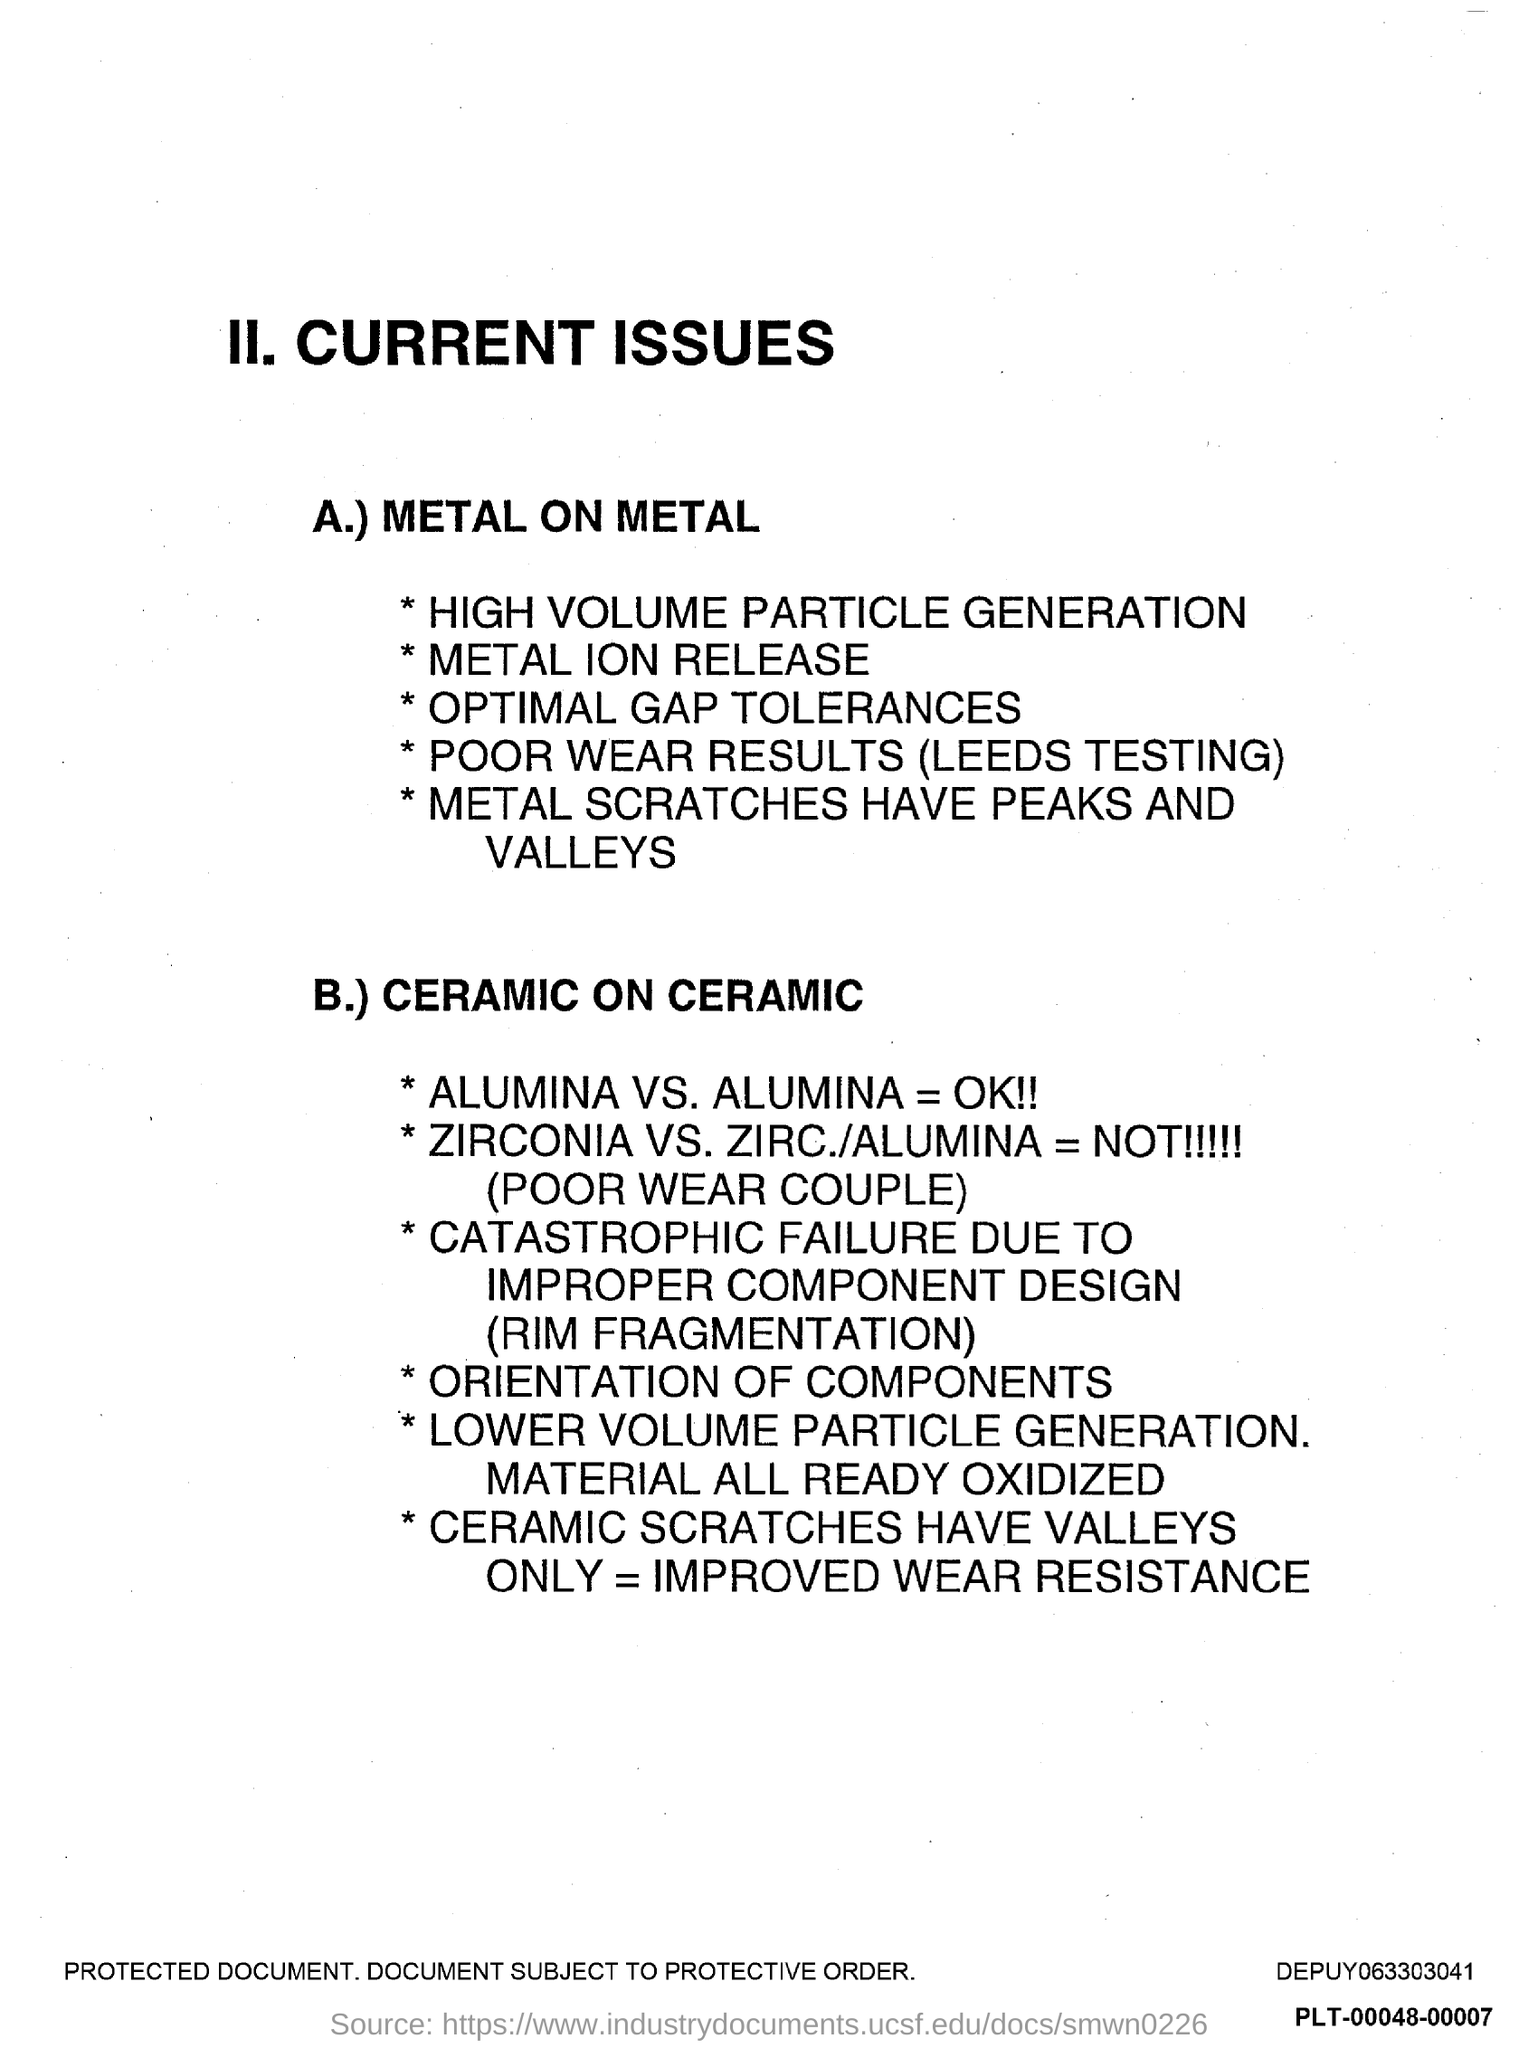What is the first title in the document?
Offer a terse response. II. Current Issues. 